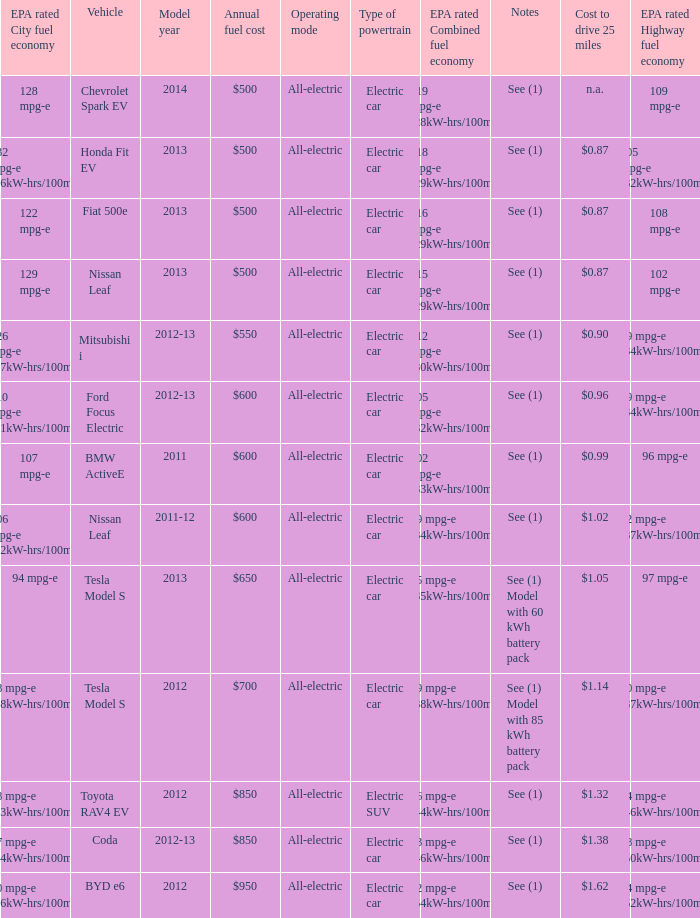What vehicle has an epa highway fuel economy of 109 mpg-e? Chevrolet Spark EV. 